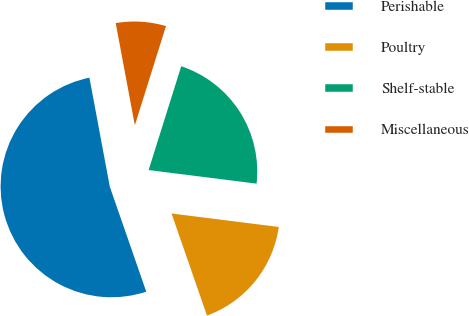Convert chart. <chart><loc_0><loc_0><loc_500><loc_500><pie_chart><fcel>Perishable<fcel>Poultry<fcel>Shelf-stable<fcel>Miscellaneous<nl><fcel>52.38%<fcel>17.69%<fcel>22.15%<fcel>7.79%<nl></chart> 